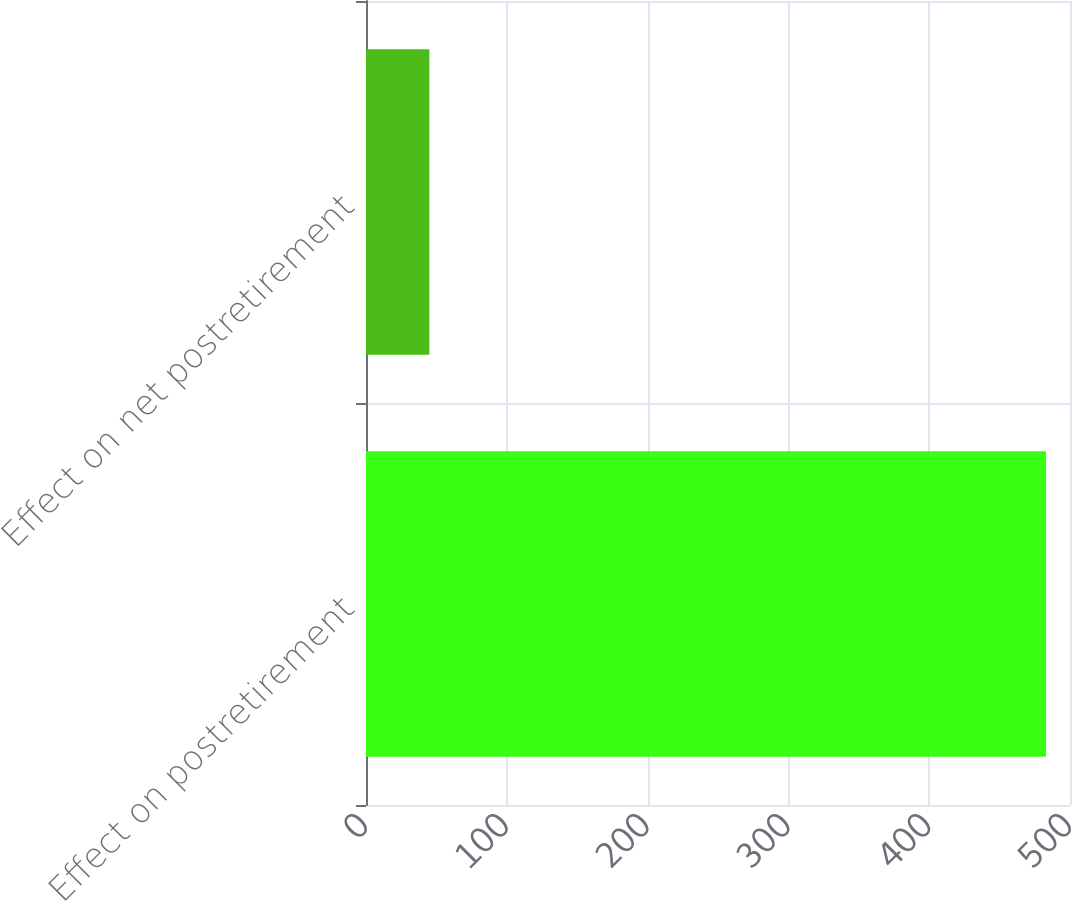<chart> <loc_0><loc_0><loc_500><loc_500><bar_chart><fcel>Effect on postretirement<fcel>Effect on net postretirement<nl><fcel>483<fcel>45<nl></chart> 